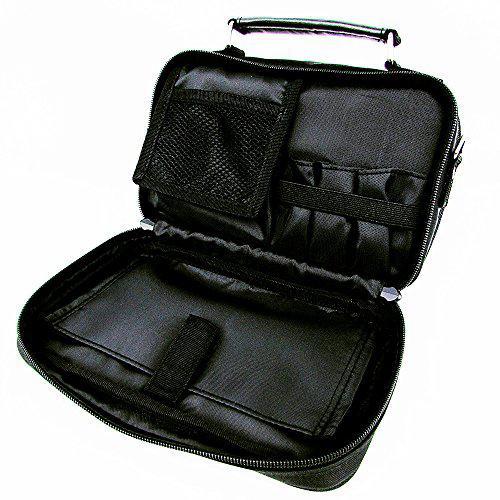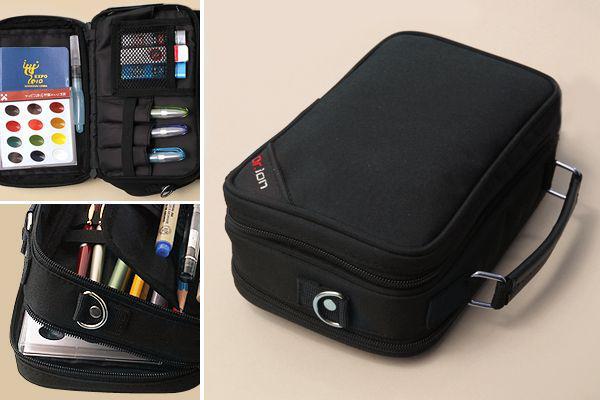The first image is the image on the left, the second image is the image on the right. For the images displayed, is the sentence "At least two of the cases are open." factually correct? Answer yes or no. Yes. 